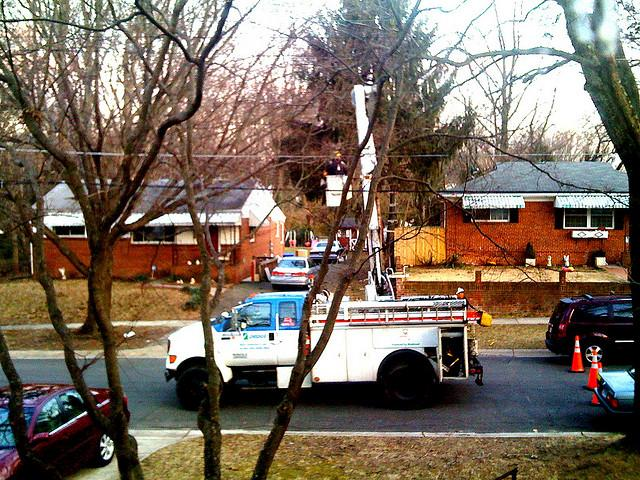Who is the man in the white platform? electrician 